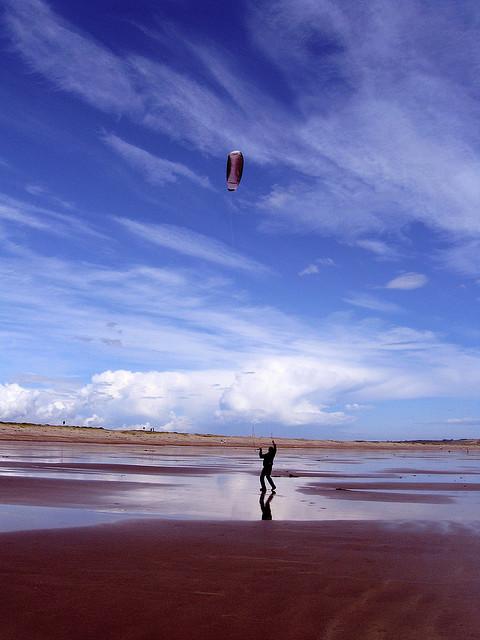How many people?
Answer briefly. 1. What is the weather like?
Short answer required. Cloudy. What is in the sky?
Give a very brief answer. Kite. What activity are they going to do with that board?
Give a very brief answer. Fly kite. 